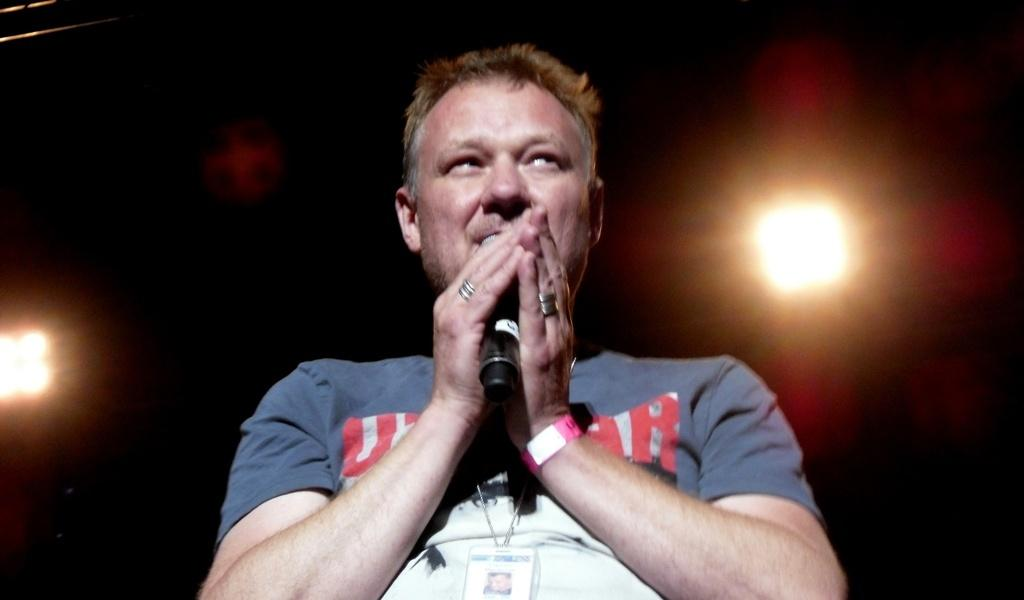What is the person in the image wearing? The person is wearing a white and grey t-shirt in the image. What is the person holding in the image? The person is holding a microphone. What can be seen in the background of the image? There are lights visible in the background of the image. How does the person stop the earth from spinning in the image? The person is not shown stopping the earth from spinning in the image; they are holding a microphone and wearing a white and grey t-shirt. 